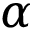<formula> <loc_0><loc_0><loc_500><loc_500>\alpha</formula> 